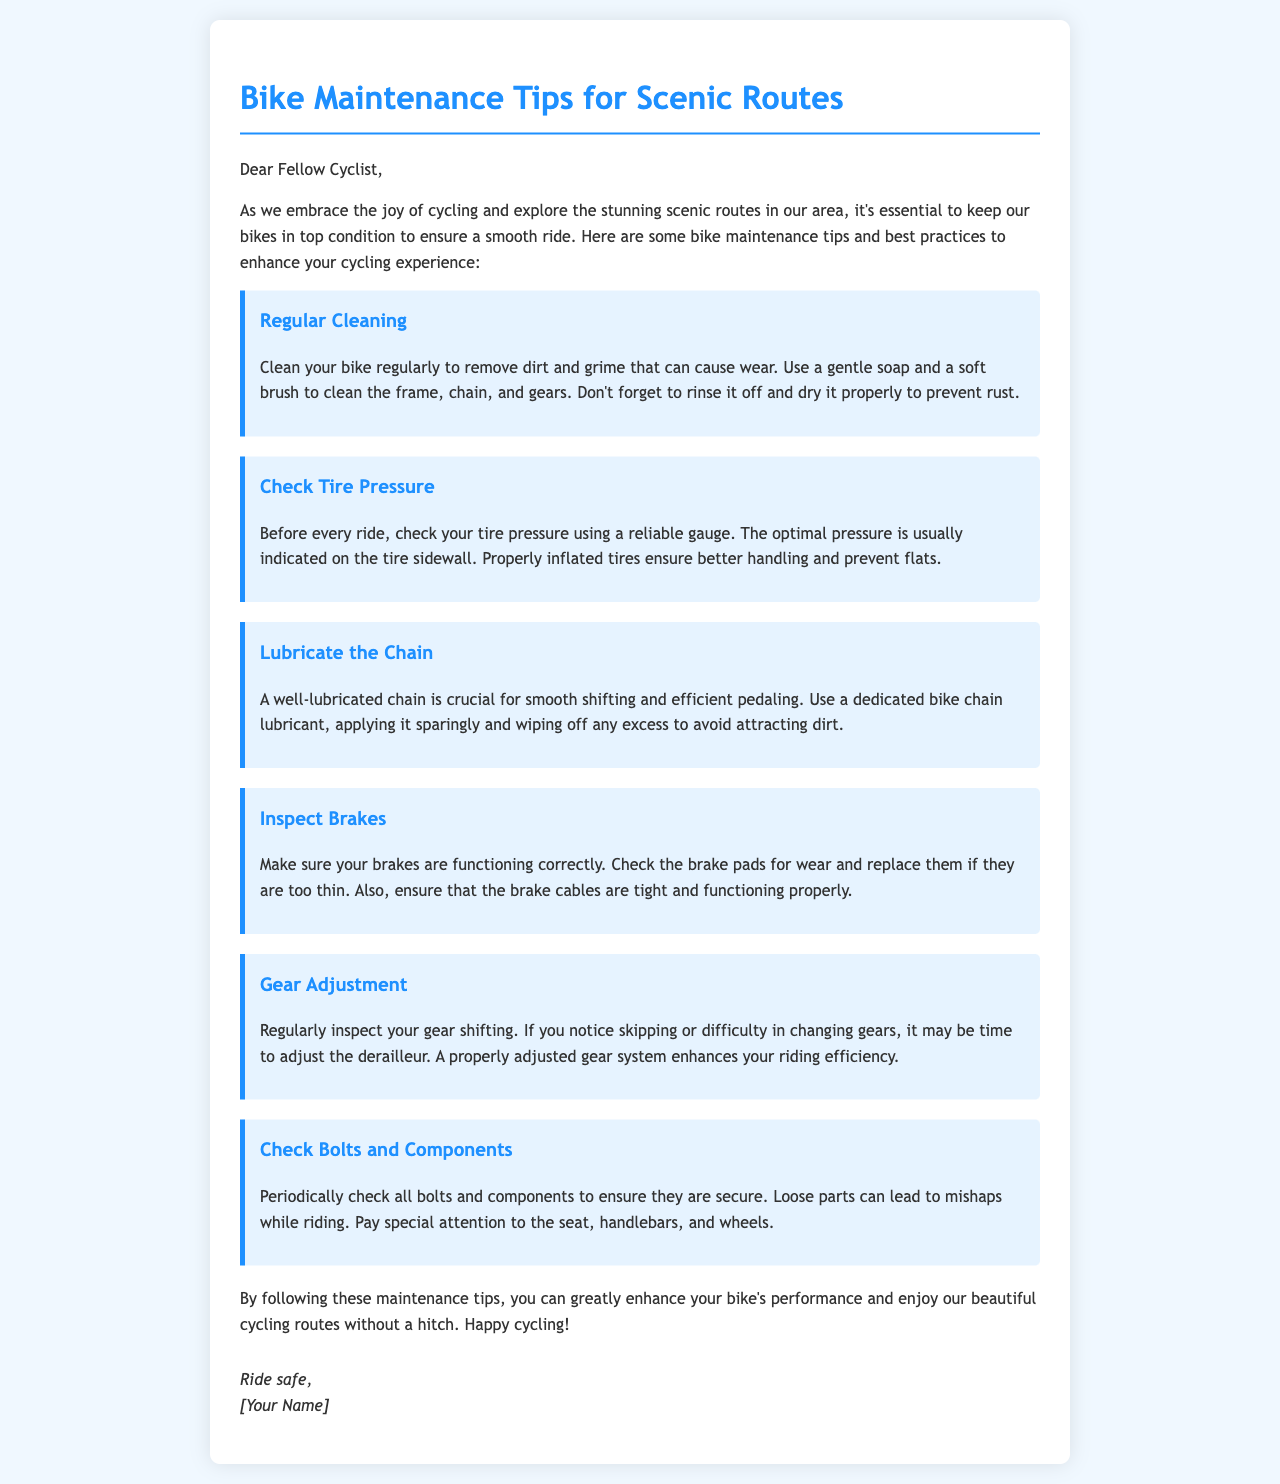what is the title of the document? The title of the document is displayed prominently at the top and introduces the main topic of the letter.
Answer: Bike Maintenance Tips for Scenic Routes what should you do before every ride? The document advises that checking tire pressure is an important step to take prior to riding.
Answer: Check Tire Pressure what is recommended for lubricating the chain? The document mentions using a specific type of lubricant for the bike chain for maintenance.
Answer: Dedicated bike chain lubricant what should you inspect regularly? The document highlights several bike components that require regular inspection for optimal performance.
Answer: Gear shifting how can you enhance your bike's performance? The document suggests several maintenance practices that contribute to improved bike performance.
Answer: Following maintenance tips why is it important to check brake pads? The document states checking brake pads is essential to ensure they are not too worn down for safe riding.
Answer: For safety while riding how should you clean your bike? The document provides guidance on how to effectively clean your bike to maintain its condition.
Answer: Use a gentle soap and a soft brush who is the author of the letter? The letter ends with a signature line indicating the person who wrote it.
Answer: [Your Name] 